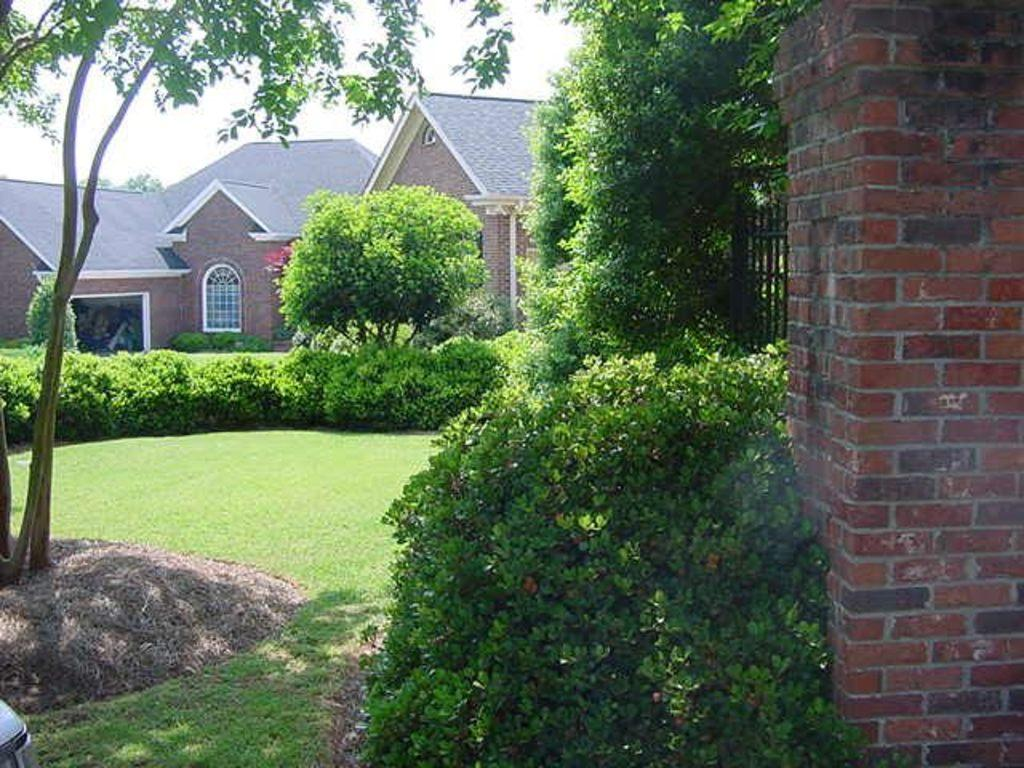What type of structure is located on the right side of the image? There is a brick wall on the right side of the image. What can be seen in the middle of the image? There are plants in the middle of the image. What is visible in the background of the image? There are houses visible in the background of the image. What type of vegetation is on the left side of the image? There are trees on the left side of the image. Can you tell me how many basketballs are visible in the image? There are no basketballs present in the image. What type of ocean is visible in the image? There is no ocean present in the image. 